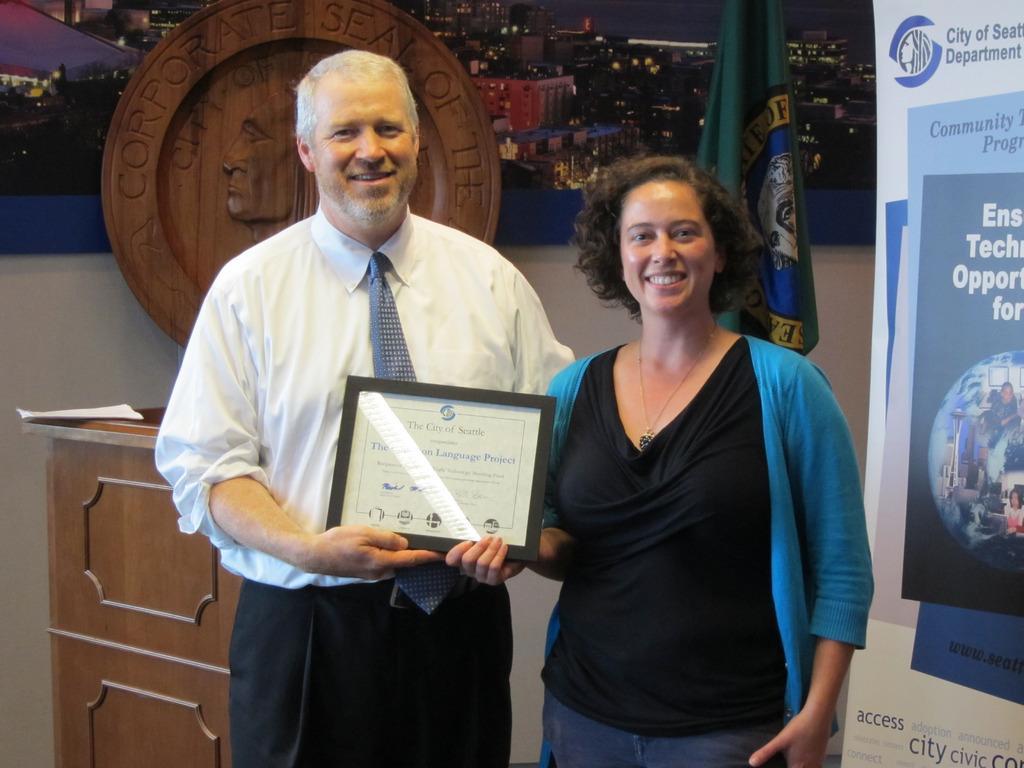Describe this image in one or two sentences. In the foreground of the picture I can see two persons and there is a smile on their faces. There is a woman on the right side and she is holding the memento shield. I can see a man on the left side is wearing a white color shirt and tie. I can see the banner on the right side. It is looking like a wooden podium on the left side and there are papers on the wooden podium. In the background, I can see the hoarding board on the wall. There is a flag on the right side and I can see a wooden logo on the left side. 